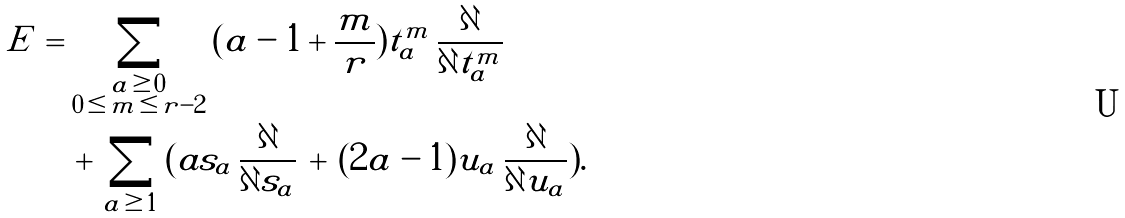Convert formula to latex. <formula><loc_0><loc_0><loc_500><loc_500>E \, = \, & \sum _ { \substack { a \, \geq \, 0 \\ 0 \, \leq \, m \, \leq \, r - 2 } } \, ( a - 1 + \frac { m } { r } ) t _ { a } ^ { m } \, \frac { \partial } { \partial t _ { a } ^ { m } } \, \\ & + \, \sum _ { a \, \geq \, 1 } \, ( a s _ { a } \, \frac { \partial } { \partial s _ { a } } \, + \, ( 2 a - 1 ) u _ { a } \, \frac { \partial } { \partial u _ { a } } ) . \,</formula> 